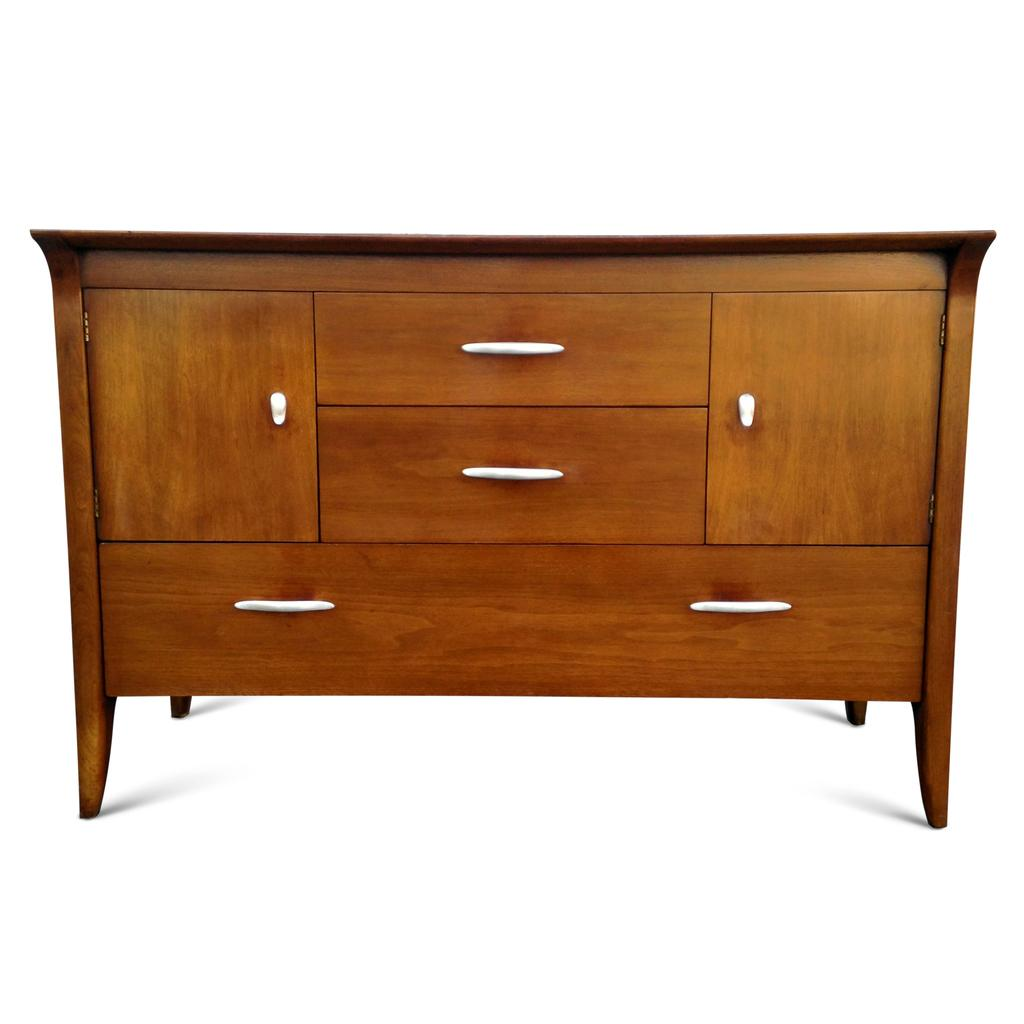What type of furniture is present in the image? There is a wooden table in the image. What other storage features can be seen in the image? There are cupboards and drawers in the image. What are the holders used for in the image? The holders are likely used for organizing or storing items. What color are the holders at the bottom of the image? The holders at the bottom are white-colored. What is the value of the boys in the market in the image? There are no boys or market present in the image; it features a wooden table, cupboards, drawers, and holders. 